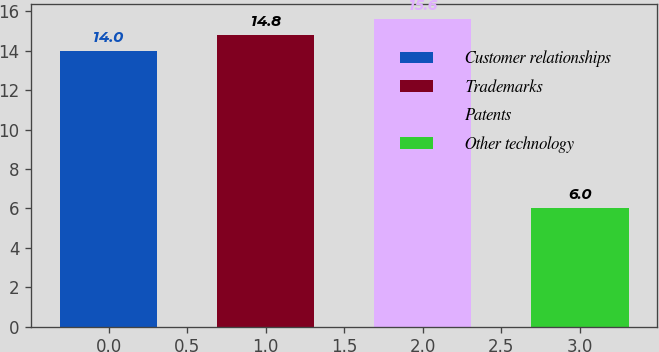Convert chart to OTSL. <chart><loc_0><loc_0><loc_500><loc_500><bar_chart><fcel>Customer relationships<fcel>Trademarks<fcel>Patents<fcel>Other technology<nl><fcel>14<fcel>14.8<fcel>15.6<fcel>6<nl></chart> 